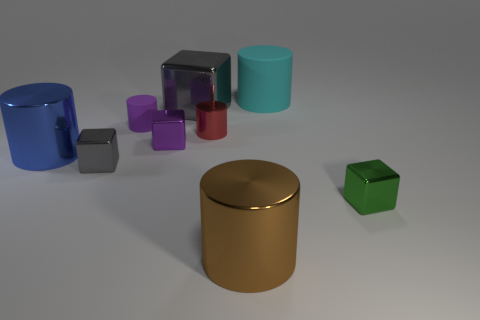Is there any other thing that has the same size as the red metallic cylinder?
Your answer should be compact. Yes. What size is the object that is the same color as the tiny matte cylinder?
Give a very brief answer. Small. There is a rubber cylinder left of the big cylinder behind the big gray thing; what number of big things are to the right of it?
Keep it short and to the point. 3. Does the tiny shiny object that is to the right of the big brown metal cylinder have the same shape as the purple thing that is in front of the small red cylinder?
Provide a succinct answer. Yes. What number of things are either small metallic cylinders or yellow balls?
Keep it short and to the point. 1. What material is the large object behind the gray shiny cube that is behind the blue metal cylinder?
Offer a very short reply. Rubber. Are there any shiny blocks of the same color as the tiny metallic cylinder?
Make the answer very short. No. There is a rubber cylinder that is the same size as the green metal object; what is its color?
Give a very brief answer. Purple. The big cylinder on the left side of the gray shiny cube that is in front of the matte cylinder that is on the left side of the large cyan cylinder is made of what material?
Make the answer very short. Metal. Does the big matte object have the same color as the thing that is in front of the green metal object?
Provide a succinct answer. No. 